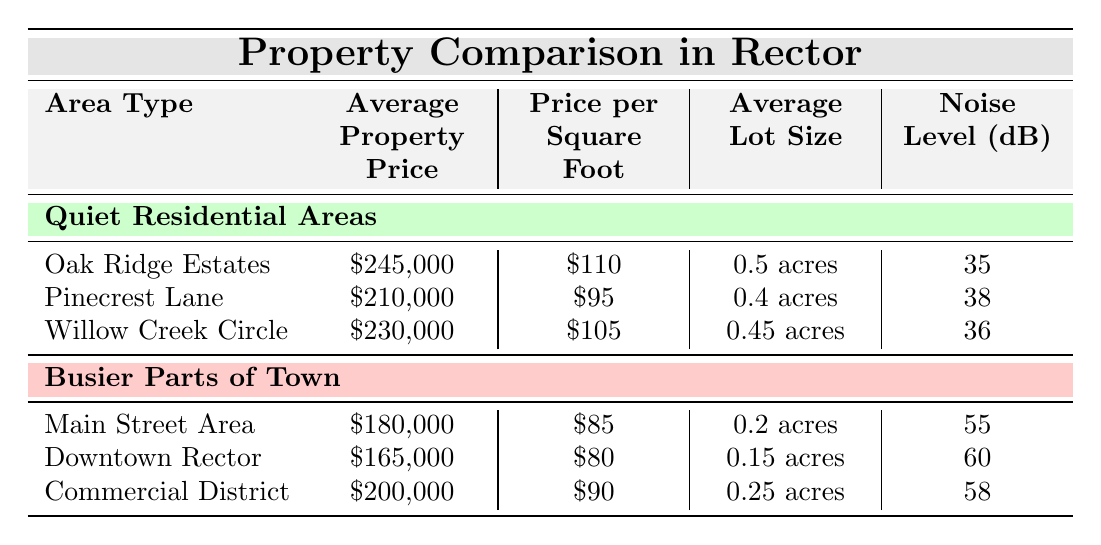What is the average property price in Quiet Residential Areas? To find the average property price in Quiet Residential Areas, we add the property prices: $245,000 + $210,000 + $230,000 = $685,000. Then, we divide by the number of properties (3), which gives us $685,000 / 3 = $228,333.33 (approximately $228,333).
Answer: $228,333 Which area has the highest noise level? By comparing the noise levels listed, I can see that Downtown Rector has a noise level of 60 dB, which is higher than any other area listed.
Answer: Downtown Rector What is the average lot size in the Busier Parts of Town? The average lot sizes in the busier parts are 0.2, 0.15, and 0.25 acres. Adding them up gives 0.2 + 0.15 + 0.25 = 0.6 acres. Dividing by the number of areas (3), we get 0.6 / 3 = 0.2 acres.
Answer: 0.2 acres Is the price per square foot lower in Quiet Residential Areas than in Busier Parts of Town? I compare the average price per square foot of both areas. In the Quiet Residential Areas, the average is $110, and in the Busier Parts of Town, it is $85. Since $110 is greater than $85, it is not lower.
Answer: No What is the difference in average property prices between the Quiet Residential Areas and the Busier Parts of Town? I calculate the average property price for the Quiet Residential Areas as $228,333 (as calculated in the first question) and the average for the Busier Parts of Town: $180,000 + $165,000 + $200,000 = $545,000, then divide by 3 to get $545,000 / 3 = $181,666.67. Thus, the difference is $228,333 - $181,666.67 = $46,666.33 (approximately $46,666).
Answer: $46,666 What area has both a higher average property price and a lower noise level: Oak Ridge Estates or Commercial District? Oak Ridge Estates has an average property price of $245,000 and a noise level of 35 dB, while Commercial District has an average property price of $200,000 and a noise level of 58 dB. Since Oak Ridge Estates has a higher price and lower noise level, it meets both criteria.
Answer: Oak Ridge Estates 